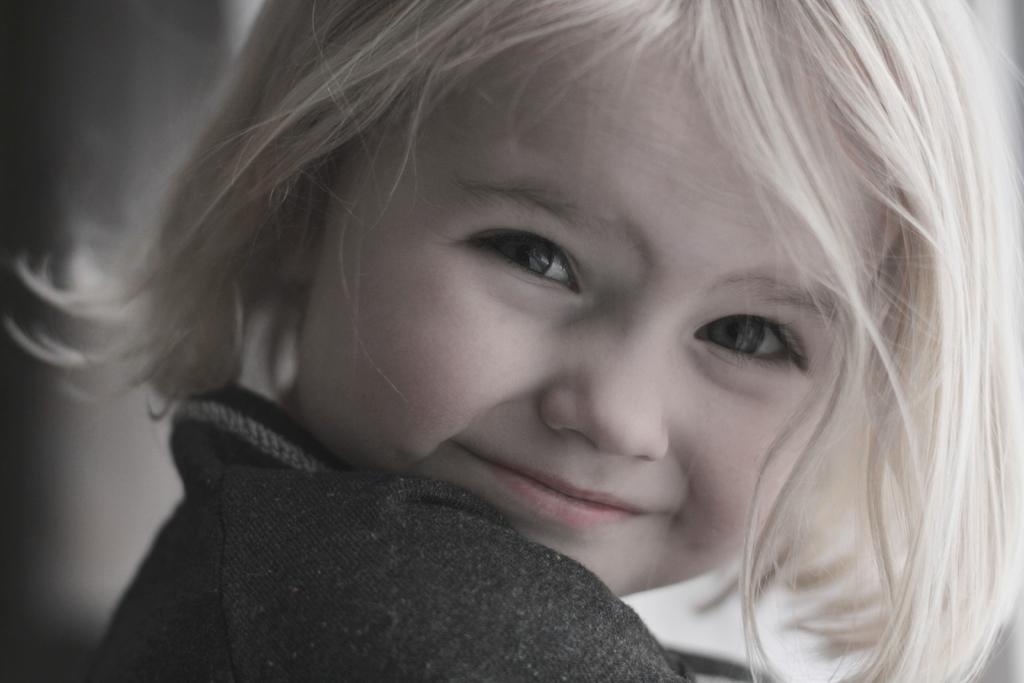What is the main subject of the image? There is a kid in the image. Can you describe the background of the image? The background of the image is blurred. What type of meat is the kid holding in the image? There is no meat present in the image; it features a kid with a blurred background. What animal can be seen in the image? There are no animals visible in the image, only a kid and a blurred background. 